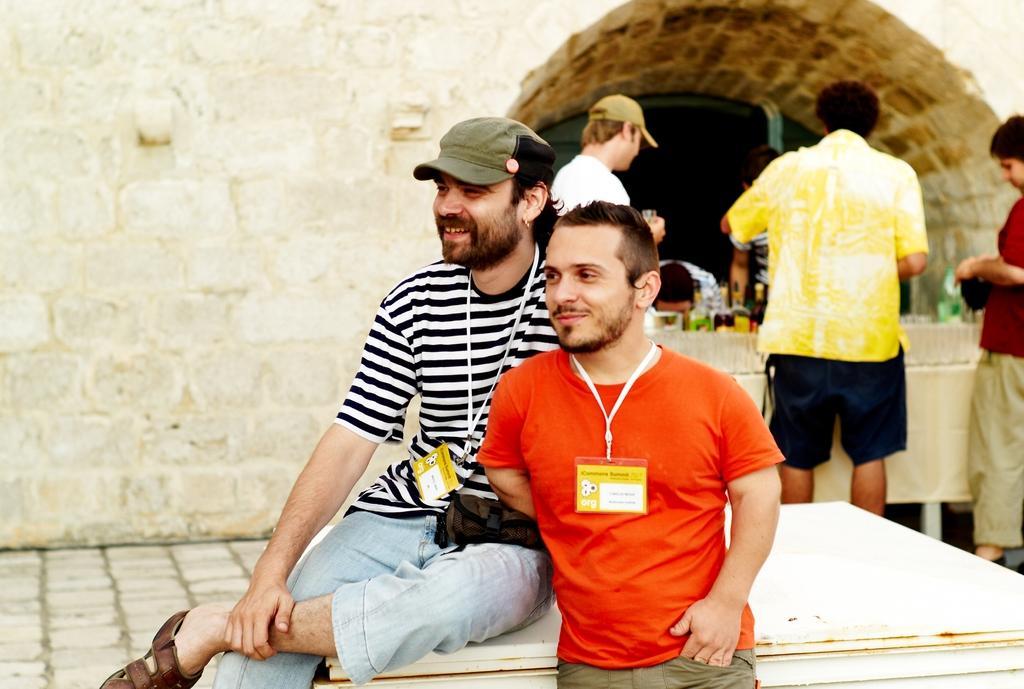Describe this image in one or two sentences. There are people and these two people smiling and wire tags. In the background we can see wall and bottles. 